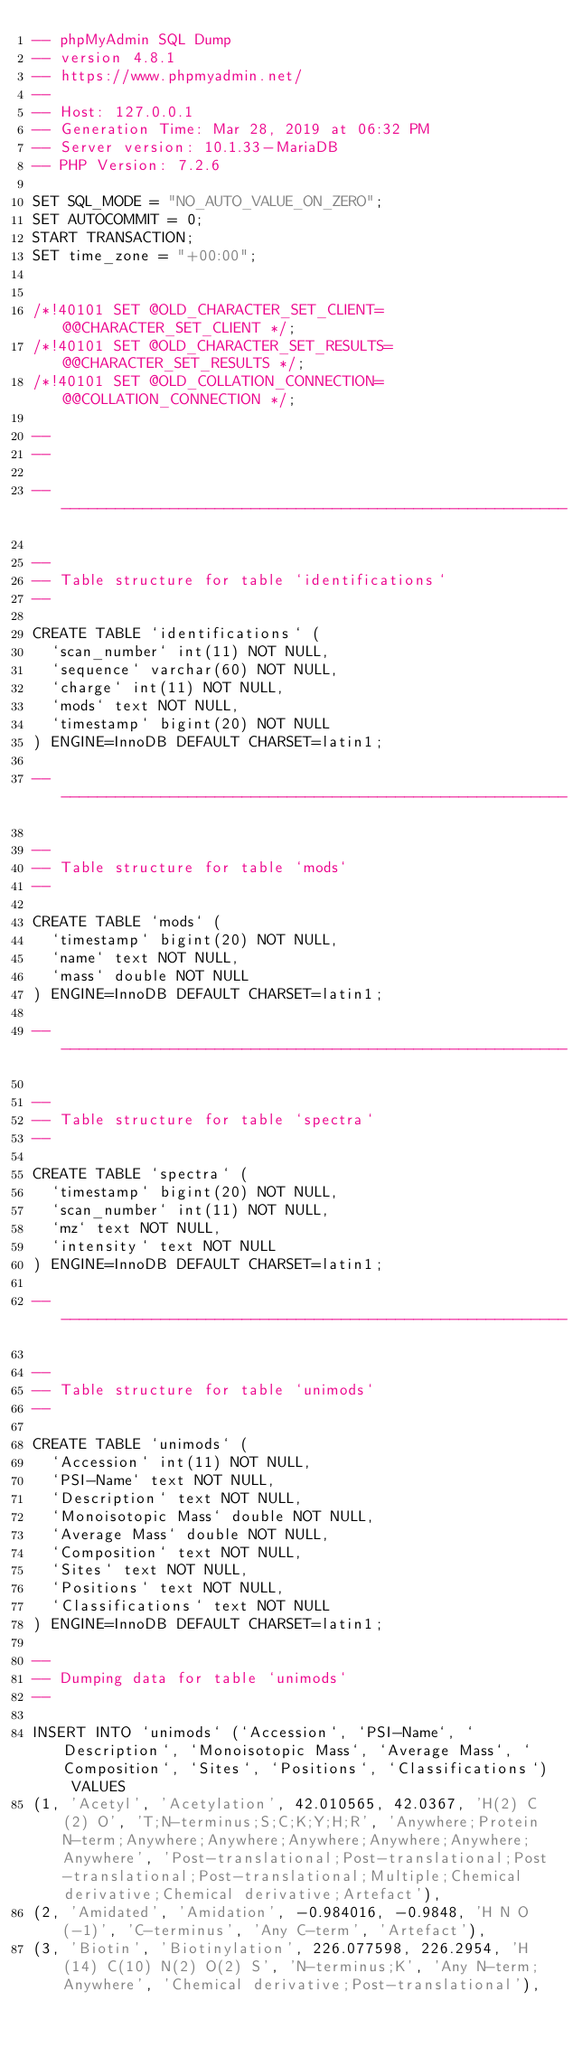Convert code to text. <code><loc_0><loc_0><loc_500><loc_500><_SQL_>-- phpMyAdmin SQL Dump
-- version 4.8.1
-- https://www.phpmyadmin.net/
--
-- Host: 127.0.0.1
-- Generation Time: Mar 28, 2019 at 06:32 PM
-- Server version: 10.1.33-MariaDB
-- PHP Version: 7.2.6

SET SQL_MODE = "NO_AUTO_VALUE_ON_ZERO";
SET AUTOCOMMIT = 0;
START TRANSACTION;
SET time_zone = "+00:00";


/*!40101 SET @OLD_CHARACTER_SET_CLIENT=@@CHARACTER_SET_CLIENT */;
/*!40101 SET @OLD_CHARACTER_SET_RESULTS=@@CHARACTER_SET_RESULTS */;
/*!40101 SET @OLD_COLLATION_CONNECTION=@@COLLATION_CONNECTION */;

--
--

-- --------------------------------------------------------

--
-- Table structure for table `identifications`
--

CREATE TABLE `identifications` (
  `scan_number` int(11) NOT NULL,
  `sequence` varchar(60) NOT NULL,
  `charge` int(11) NOT NULL,
  `mods` text NOT NULL,
  `timestamp` bigint(20) NOT NULL
) ENGINE=InnoDB DEFAULT CHARSET=latin1;

-- --------------------------------------------------------

--
-- Table structure for table `mods`
--

CREATE TABLE `mods` (
  `timestamp` bigint(20) NOT NULL,
  `name` text NOT NULL,
  `mass` double NOT NULL
) ENGINE=InnoDB DEFAULT CHARSET=latin1;

-- --------------------------------------------------------

--
-- Table structure for table `spectra`
--

CREATE TABLE `spectra` (
  `timestamp` bigint(20) NOT NULL,
  `scan_number` int(11) NOT NULL,
  `mz` text NOT NULL,
  `intensity` text NOT NULL
) ENGINE=InnoDB DEFAULT CHARSET=latin1;

-- --------------------------------------------------------

--
-- Table structure for table `unimods`
--

CREATE TABLE `unimods` (
  `Accession` int(11) NOT NULL,
  `PSI-Name` text NOT NULL,
  `Description` text NOT NULL,
  `Monoisotopic Mass` double NOT NULL,
  `Average Mass` double NOT NULL,
  `Composition` text NOT NULL,
  `Sites` text NOT NULL,
  `Positions` text NOT NULL,
  `Classifications` text NOT NULL
) ENGINE=InnoDB DEFAULT CHARSET=latin1;

--
-- Dumping data for table `unimods`
--

INSERT INTO `unimods` (`Accession`, `PSI-Name`, `Description`, `Monoisotopic Mass`, `Average Mass`, `Composition`, `Sites`, `Positions`, `Classifications`) VALUES
(1, 'Acetyl', 'Acetylation', 42.010565, 42.0367, 'H(2) C(2) O', 'T;N-terminus;S;C;K;Y;H;R', 'Anywhere;Protein N-term;Anywhere;Anywhere;Anywhere;Anywhere;Anywhere;Anywhere', 'Post-translational;Post-translational;Post-translational;Post-translational;Multiple;Chemical derivative;Chemical derivative;Artefact'),
(2, 'Amidated', 'Amidation', -0.984016, -0.9848, 'H N O(-1)', 'C-terminus', 'Any C-term', 'Artefact'),
(3, 'Biotin', 'Biotinylation', 226.077598, 226.2954, 'H(14) C(10) N(2) O(2) S', 'N-terminus;K', 'Any N-term;Anywhere', 'Chemical derivative;Post-translational'),</code> 